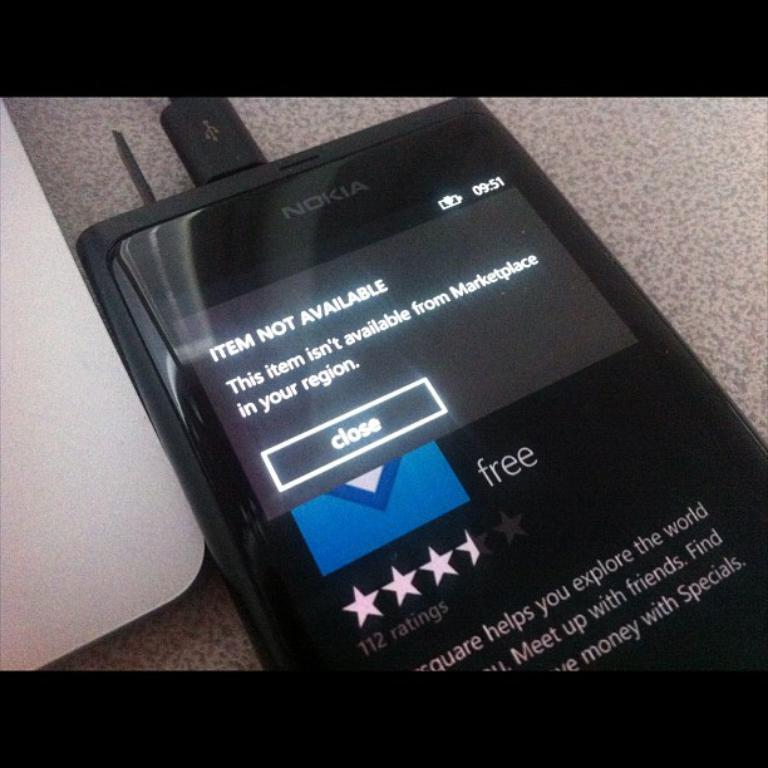<image>
Describe the image concisely. Nokia phone  with display app notification.of an unavailable 